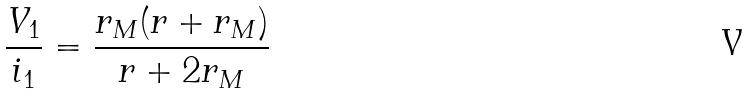Convert formula to latex. <formula><loc_0><loc_0><loc_500><loc_500>\frac { V _ { 1 } } { i _ { 1 } } = \frac { r _ { M } ( r + r _ { M } ) } { r + 2 r _ { M } }</formula> 